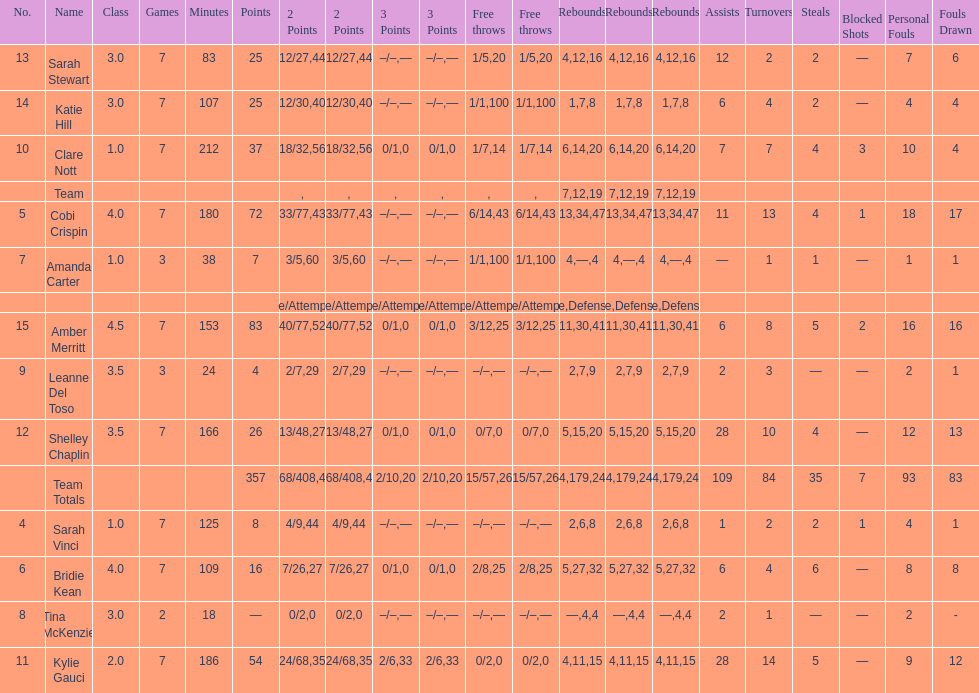Who is the first person on the list to play less than 20 minutes? Tina McKenzie. 